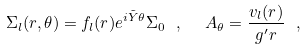<formula> <loc_0><loc_0><loc_500><loc_500>\Sigma _ { l } ( r , \theta ) = f _ { l } ( r ) e ^ { i { \tilde { Y } } \theta } \Sigma _ { 0 } \ , \ \ A _ { \theta } = \frac { v _ { l } ( r ) } { g ^ { \prime } r } \ ,</formula> 